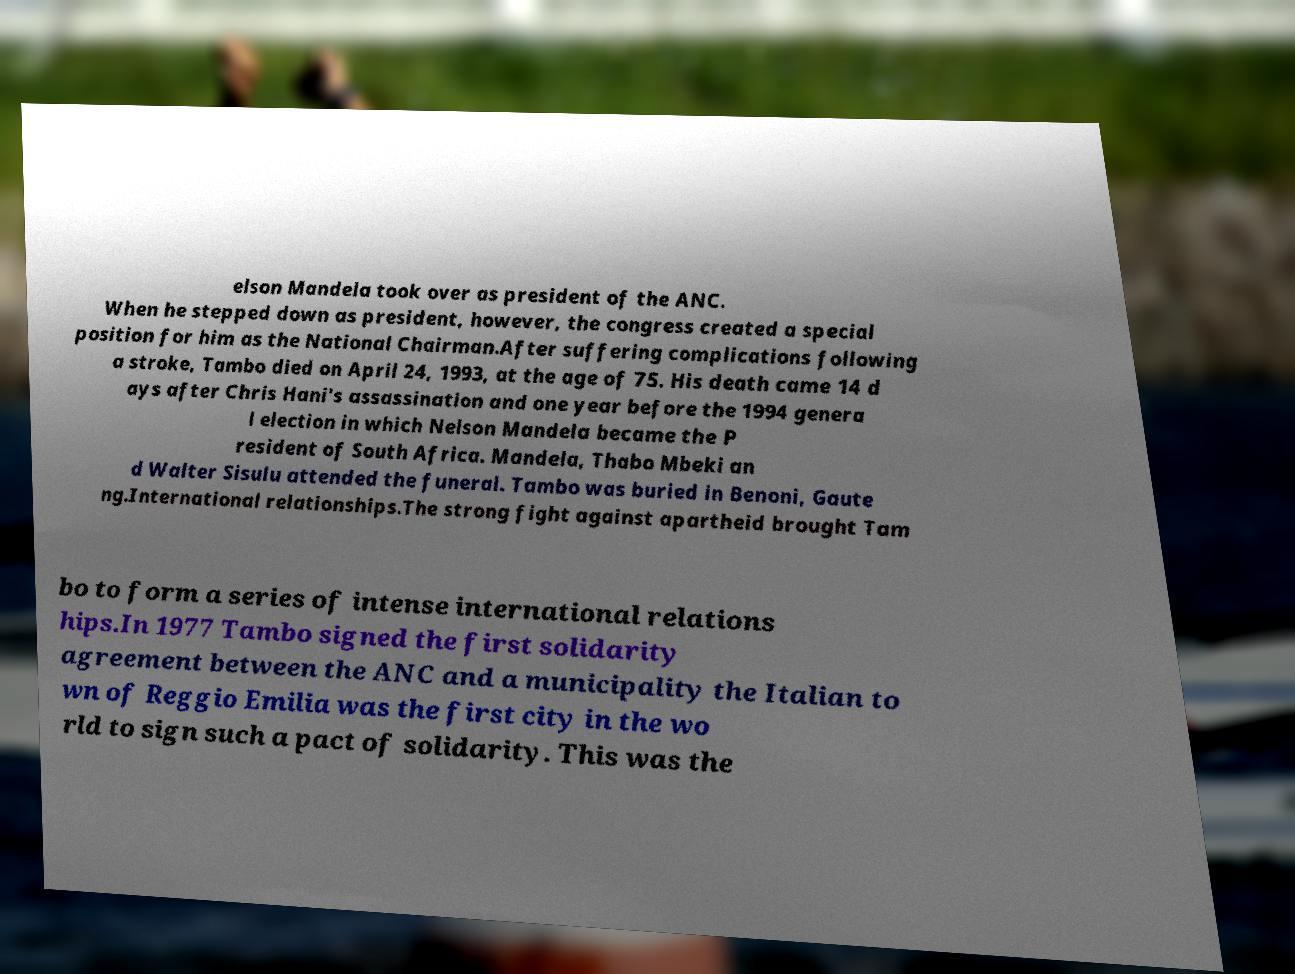Could you extract and type out the text from this image? elson Mandela took over as president of the ANC. When he stepped down as president, however, the congress created a special position for him as the National Chairman.After suffering complications following a stroke, Tambo died on April 24, 1993, at the age of 75. His death came 14 d ays after Chris Hani's assassination and one year before the 1994 genera l election in which Nelson Mandela became the P resident of South Africa. Mandela, Thabo Mbeki an d Walter Sisulu attended the funeral. Tambo was buried in Benoni, Gaute ng.International relationships.The strong fight against apartheid brought Tam bo to form a series of intense international relations hips.In 1977 Tambo signed the first solidarity agreement between the ANC and a municipality the Italian to wn of Reggio Emilia was the first city in the wo rld to sign such a pact of solidarity. This was the 